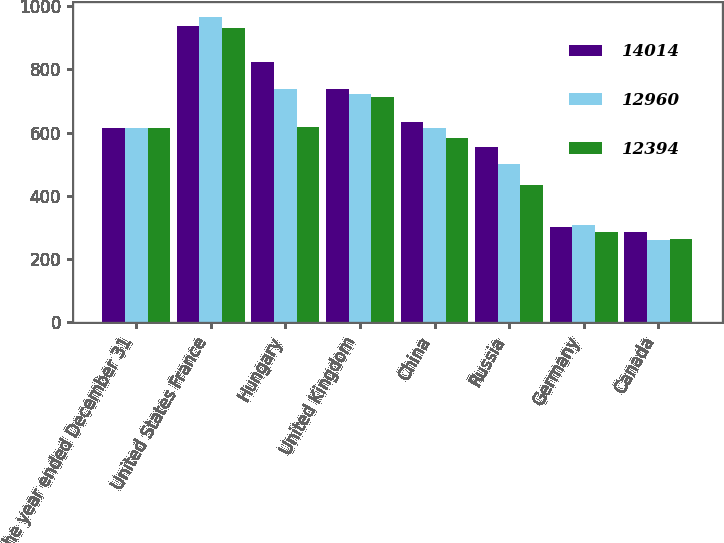Convert chart to OTSL. <chart><loc_0><loc_0><loc_500><loc_500><stacked_bar_chart><ecel><fcel>For the year ended December 31<fcel>United States France<fcel>Hungary<fcel>United Kingdom<fcel>China<fcel>Russia<fcel>Germany<fcel>Canada<nl><fcel>14014<fcel>615<fcel>936<fcel>823<fcel>737<fcel>632<fcel>553<fcel>302<fcel>285<nl><fcel>12960<fcel>615<fcel>965<fcel>739<fcel>721<fcel>615<fcel>500<fcel>309<fcel>261<nl><fcel>12394<fcel>615<fcel>930<fcel>619<fcel>711<fcel>582<fcel>433<fcel>284<fcel>262<nl></chart> 